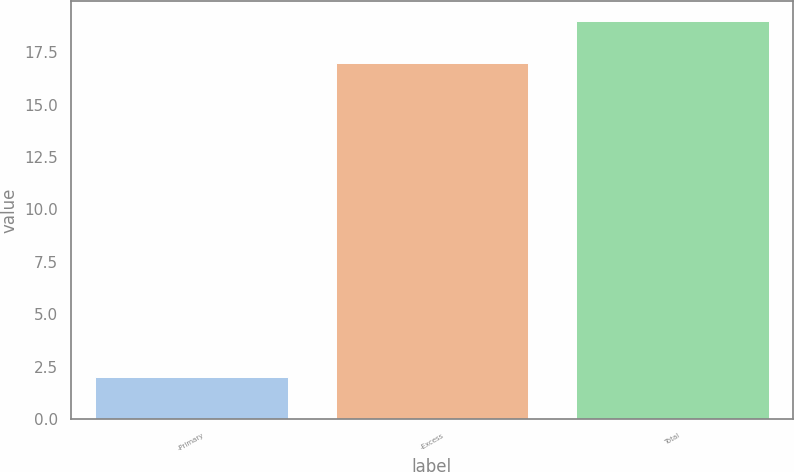<chart> <loc_0><loc_0><loc_500><loc_500><bar_chart><fcel>-Primary<fcel>-Excess<fcel>Total<nl><fcel>2<fcel>17<fcel>19<nl></chart> 